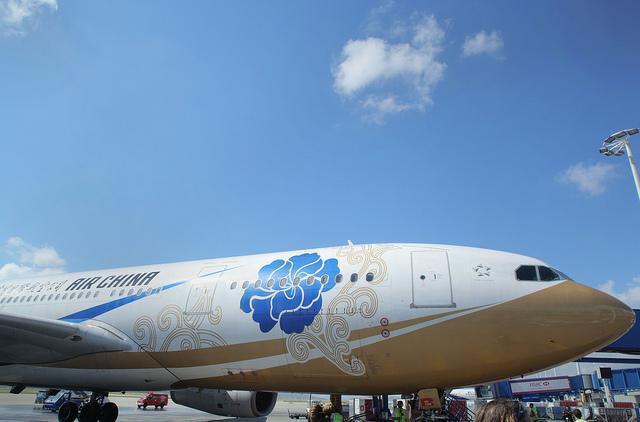How many white boats are to the side of the building?
Give a very brief answer. 0. 